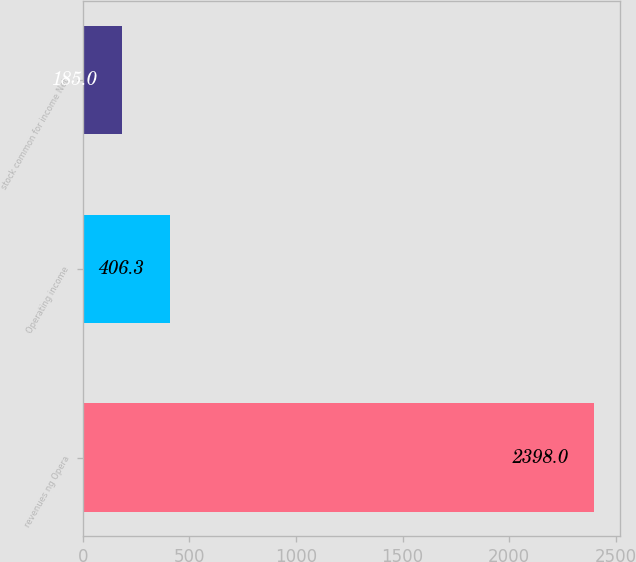<chart> <loc_0><loc_0><loc_500><loc_500><bar_chart><fcel>revenues ng Opera<fcel>Operating income<fcel>stock common for income Net<nl><fcel>2398<fcel>406.3<fcel>185<nl></chart> 